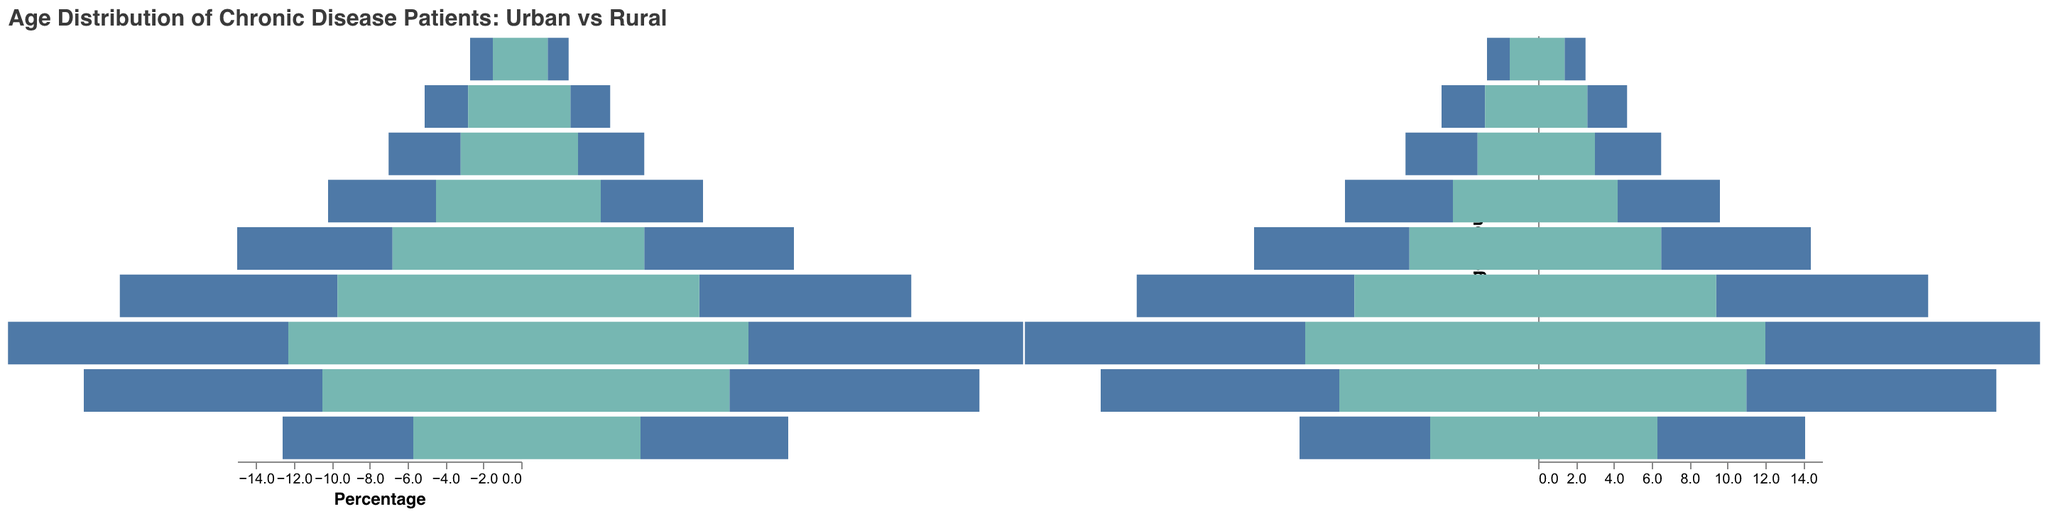What is the age range with the highest percentage of chronic disease patients for urban males? The age range with the highest percentage for urban males is identified by finding the tallest blue bar on the negative side (indicating urban males) of the population pyramid. For urban males, the highest percentage is in the 60-69 age group with 14.8%.
Answer: 60-69 Which gender and area (Urban or Rural) has the lowest percentage of patients in the 0-9 age group? To find the lowest percentage in the 0-9 age group, we compare the four bars (Urban Male, Urban Female, Rural Male, Rural Female) for that age range. Urban Female has the lowest percentage at 1.1%.
Answer: Urban Female What is the total percentage of chronic disease patients aged 50-59 in rural areas? To get the total percentage for rural areas, sum up the percentages for Rural Male (9.7%) and Rural Female (9.4%) in the 50-59 age group. The total is 9.7% + 9.4% = 19.1%.
Answer: 19.1% Compare the percentages of urban and rural females in the 70-79 age group. Which group is larger and by how much? For the 70-79 age group, we compare the percentages for Urban Female (13.2%) and Rural Female (11.0%). Urban Female is higher. The difference is 13.2% - 11.0% = 2.2%.
Answer: Urban Female by 2.2% What is the combined percentage of urban females aged 30-39 and 40-49? To find the combined percentage, add the percentages for Urban Female in the 30-39 age group (5.4%) and the 40-49 age group (7.9%). The total is 5.4% + 7.9% = 13.3%.
Answer: 13.3% In which age group do rural males have the closest percentage to urban males? Reviewing the data points for Rural Male and Urban Male, their closest percentages occurred in the 20-29 age group, where Rural Males have 3.2% and Urban Males have 3.8%, differing by only 0.6%.
Answer: 20-29 Which two age groups have the most significant gap in percentages between urban and rural males? Comparing the differences between Urban Males and Rural Males across the age groups, the 60-69 age group has a difference of 14.8% - 12.3% = 2.5%, and the 50-59 age group has a difference of 11.5% - 9.7% = 1.8%. The most significant gap is 2.5% in the 60-69 age group.
Answer: 60-69 How does the percentage of chronic disease patients aged 80+ compare between urban and rural areas for males? To compare, look at the percentages of Urban Male (6.9%) and Rural Male (5.7%) in the 80+ age group. Urban Males have a higher percentage by 6.9% - 5.7% = 1.2%.
Answer: Urban Males higher by 1.2% 